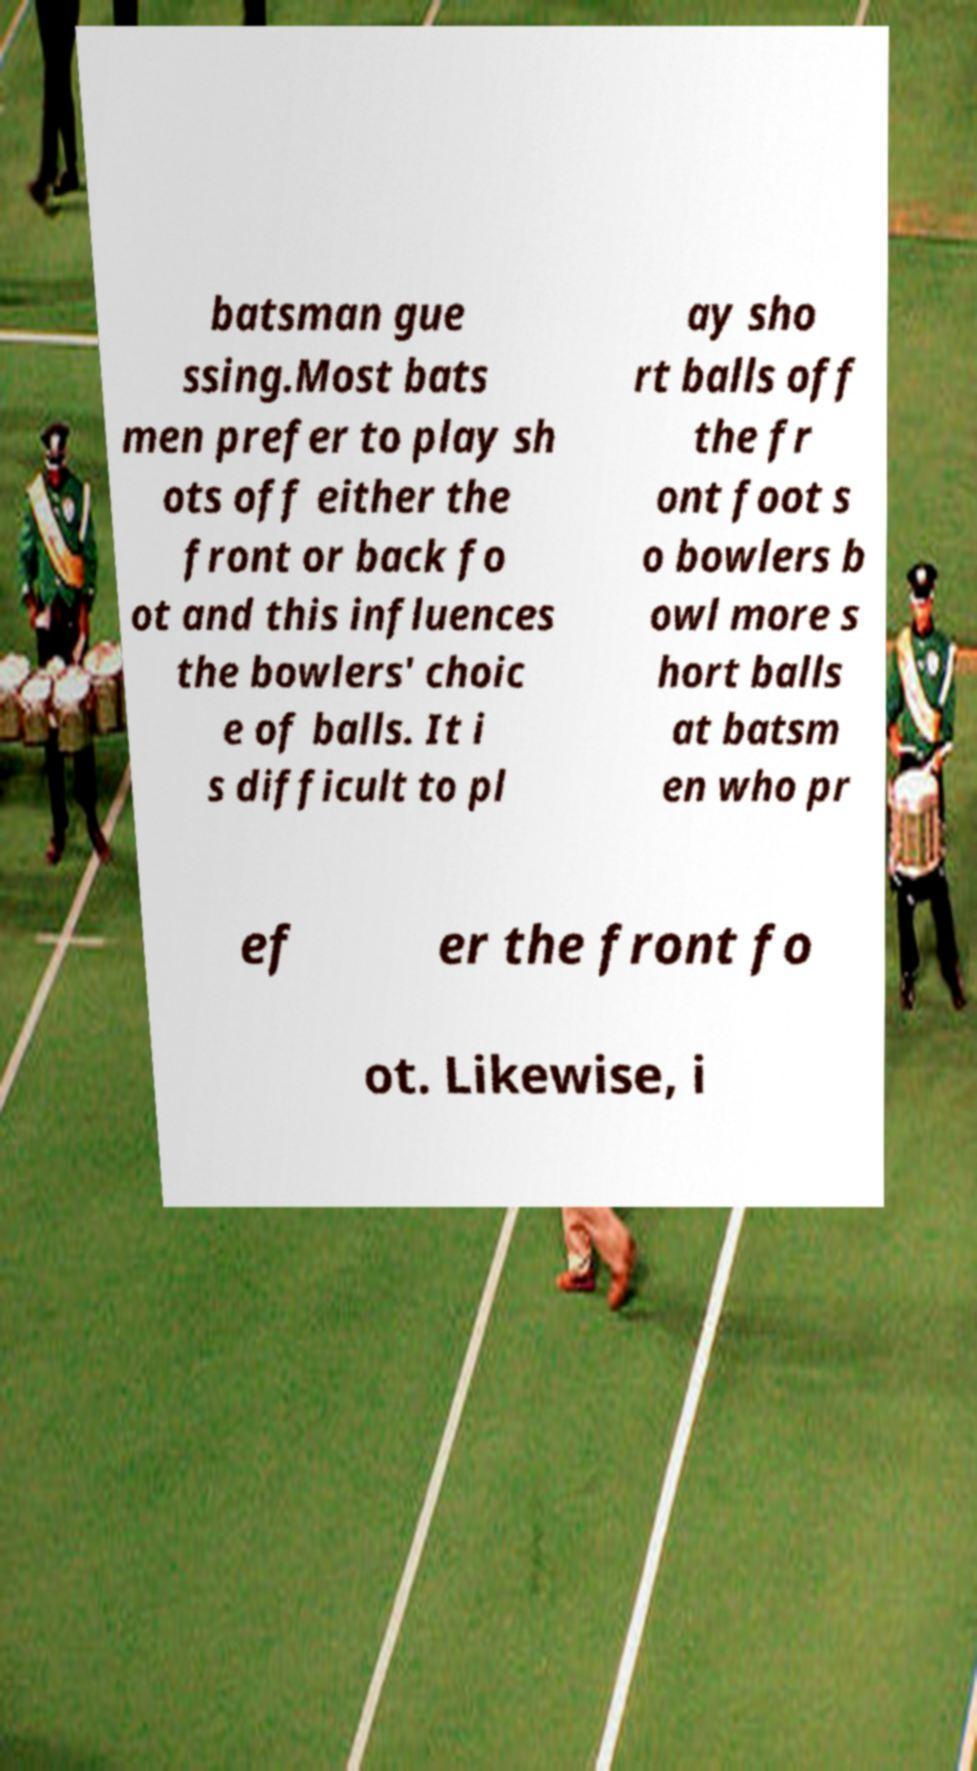I need the written content from this picture converted into text. Can you do that? batsman gue ssing.Most bats men prefer to play sh ots off either the front or back fo ot and this influences the bowlers' choic e of balls. It i s difficult to pl ay sho rt balls off the fr ont foot s o bowlers b owl more s hort balls at batsm en who pr ef er the front fo ot. Likewise, i 